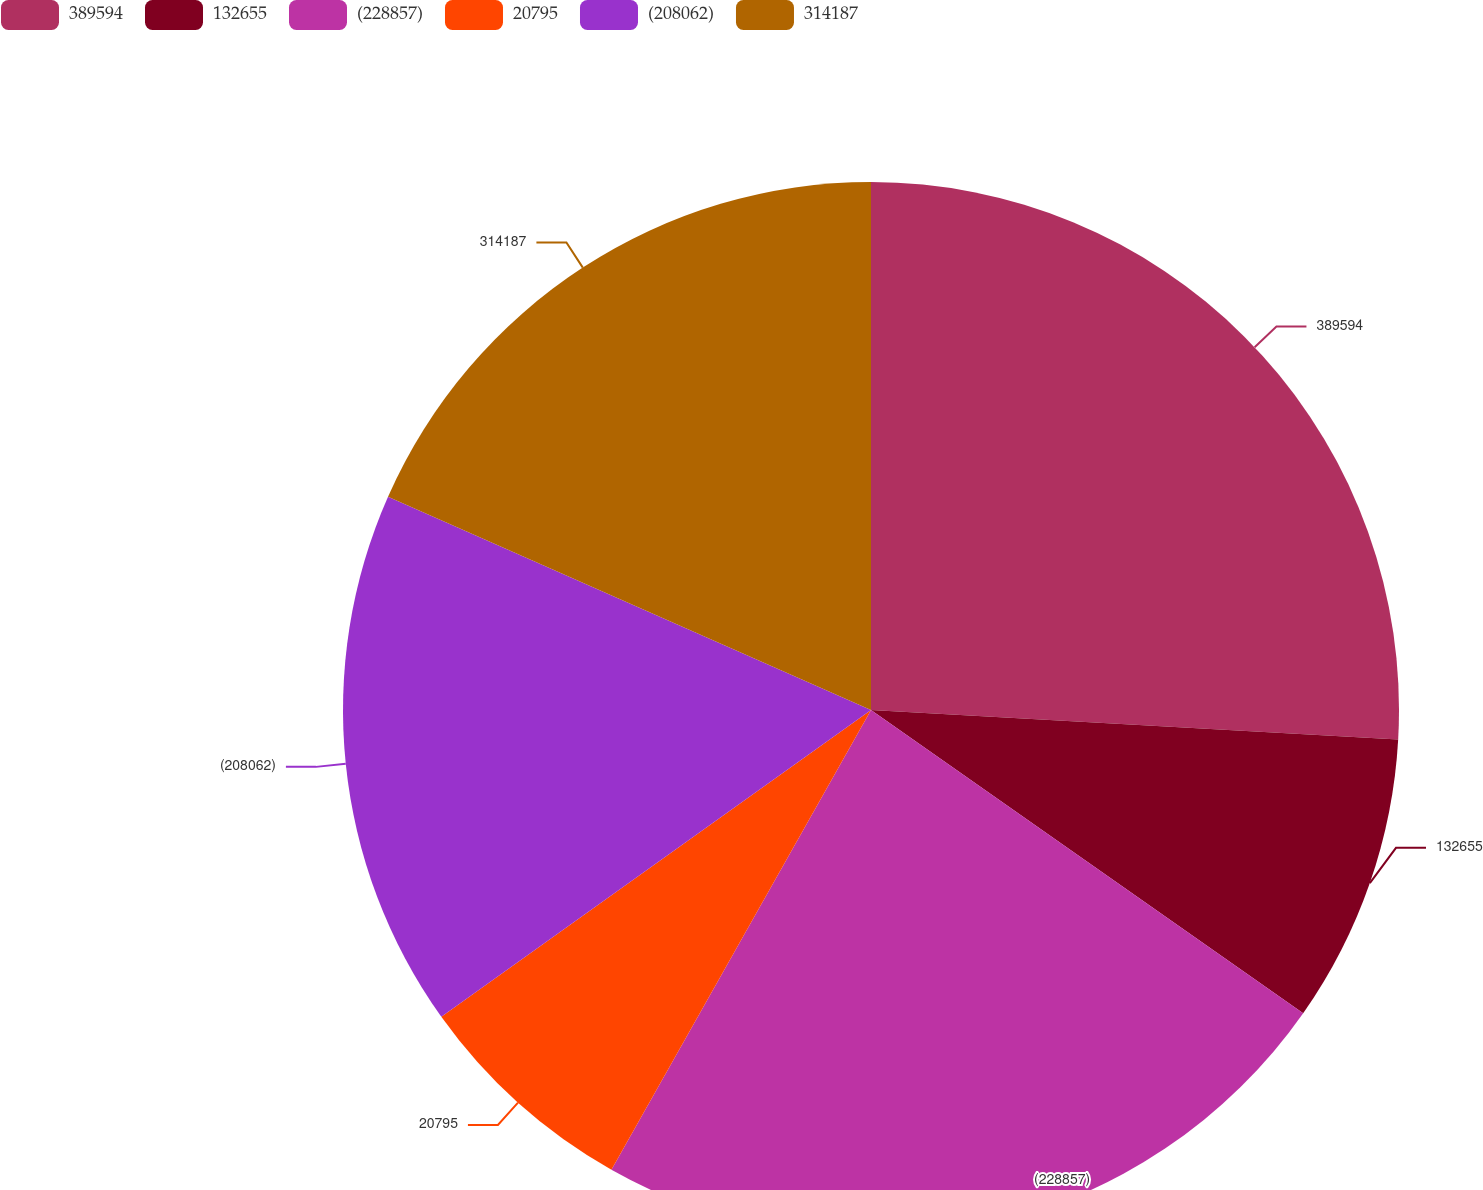Convert chart. <chart><loc_0><loc_0><loc_500><loc_500><pie_chart><fcel>389594<fcel>132655<fcel>(228857)<fcel>20795<fcel>(208062)<fcel>314187<nl><fcel>25.89%<fcel>8.85%<fcel>23.44%<fcel>6.95%<fcel>16.49%<fcel>18.38%<nl></chart> 